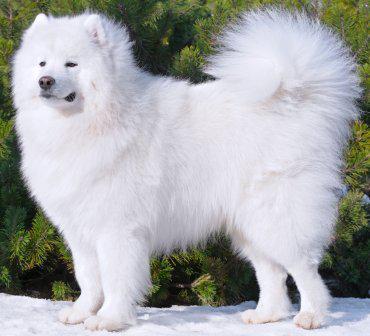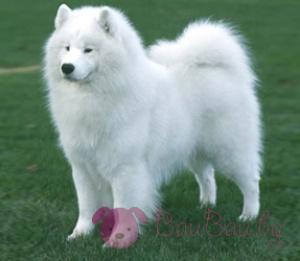The first image is the image on the left, the second image is the image on the right. Evaluate the accuracy of this statement regarding the images: "The dogs have their mouths open.". Is it true? Answer yes or no. No. 